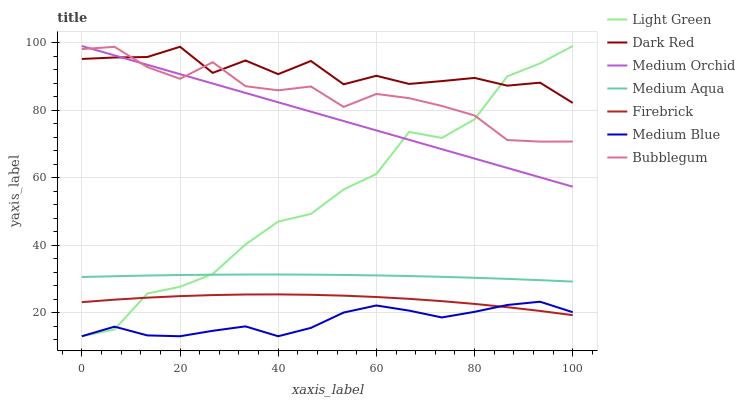Does Medium Blue have the minimum area under the curve?
Answer yes or no. Yes. Does Dark Red have the maximum area under the curve?
Answer yes or no. Yes. Does Firebrick have the minimum area under the curve?
Answer yes or no. No. Does Firebrick have the maximum area under the curve?
Answer yes or no. No. Is Medium Orchid the smoothest?
Answer yes or no. Yes. Is Light Green the roughest?
Answer yes or no. Yes. Is Firebrick the smoothest?
Answer yes or no. No. Is Firebrick the roughest?
Answer yes or no. No. Does Medium Blue have the lowest value?
Answer yes or no. Yes. Does Firebrick have the lowest value?
Answer yes or no. No. Does Light Green have the highest value?
Answer yes or no. Yes. Does Firebrick have the highest value?
Answer yes or no. No. Is Firebrick less than Medium Orchid?
Answer yes or no. Yes. Is Bubblegum greater than Medium Aqua?
Answer yes or no. Yes. Does Dark Red intersect Bubblegum?
Answer yes or no. Yes. Is Dark Red less than Bubblegum?
Answer yes or no. No. Is Dark Red greater than Bubblegum?
Answer yes or no. No. Does Firebrick intersect Medium Orchid?
Answer yes or no. No. 